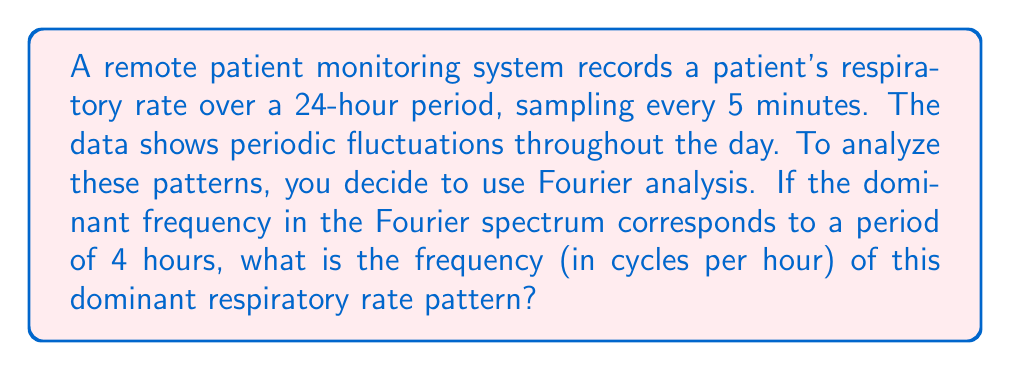Can you solve this math problem? To solve this problem, we need to understand the relationship between frequency and period in Fourier analysis. The period is the time taken for one complete cycle of a repeating pattern, while frequency is the number of cycles that occur in a given time unit.

The relationship between frequency ($f$) and period ($T$) is given by:

$$ f = \frac{1}{T} $$

Where:
- $f$ is the frequency in cycles per unit time
- $T$ is the period in units of time

In this case:
- The period $T$ is given as 4 hours
- We want to find the frequency $f$ in cycles per hour

Plugging these values into the equation:

$$ f = \frac{1}{4\text{ hours}} $$

To express this as a decimal:

$$ f = 0.25 \text{ cycles/hour} $$

This means that the dominant respiratory rate pattern repeats 0.25 times every hour, or once every 4 hours, which matches the given period.
Answer: $0.25 \text{ cycles/hour}$ 